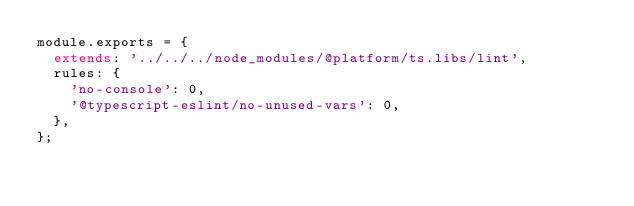<code> <loc_0><loc_0><loc_500><loc_500><_JavaScript_>module.exports = {
  extends: '../../../node_modules/@platform/ts.libs/lint',
  rules: {
    'no-console': 0,
    '@typescript-eslint/no-unused-vars': 0,
  },
};
</code> 